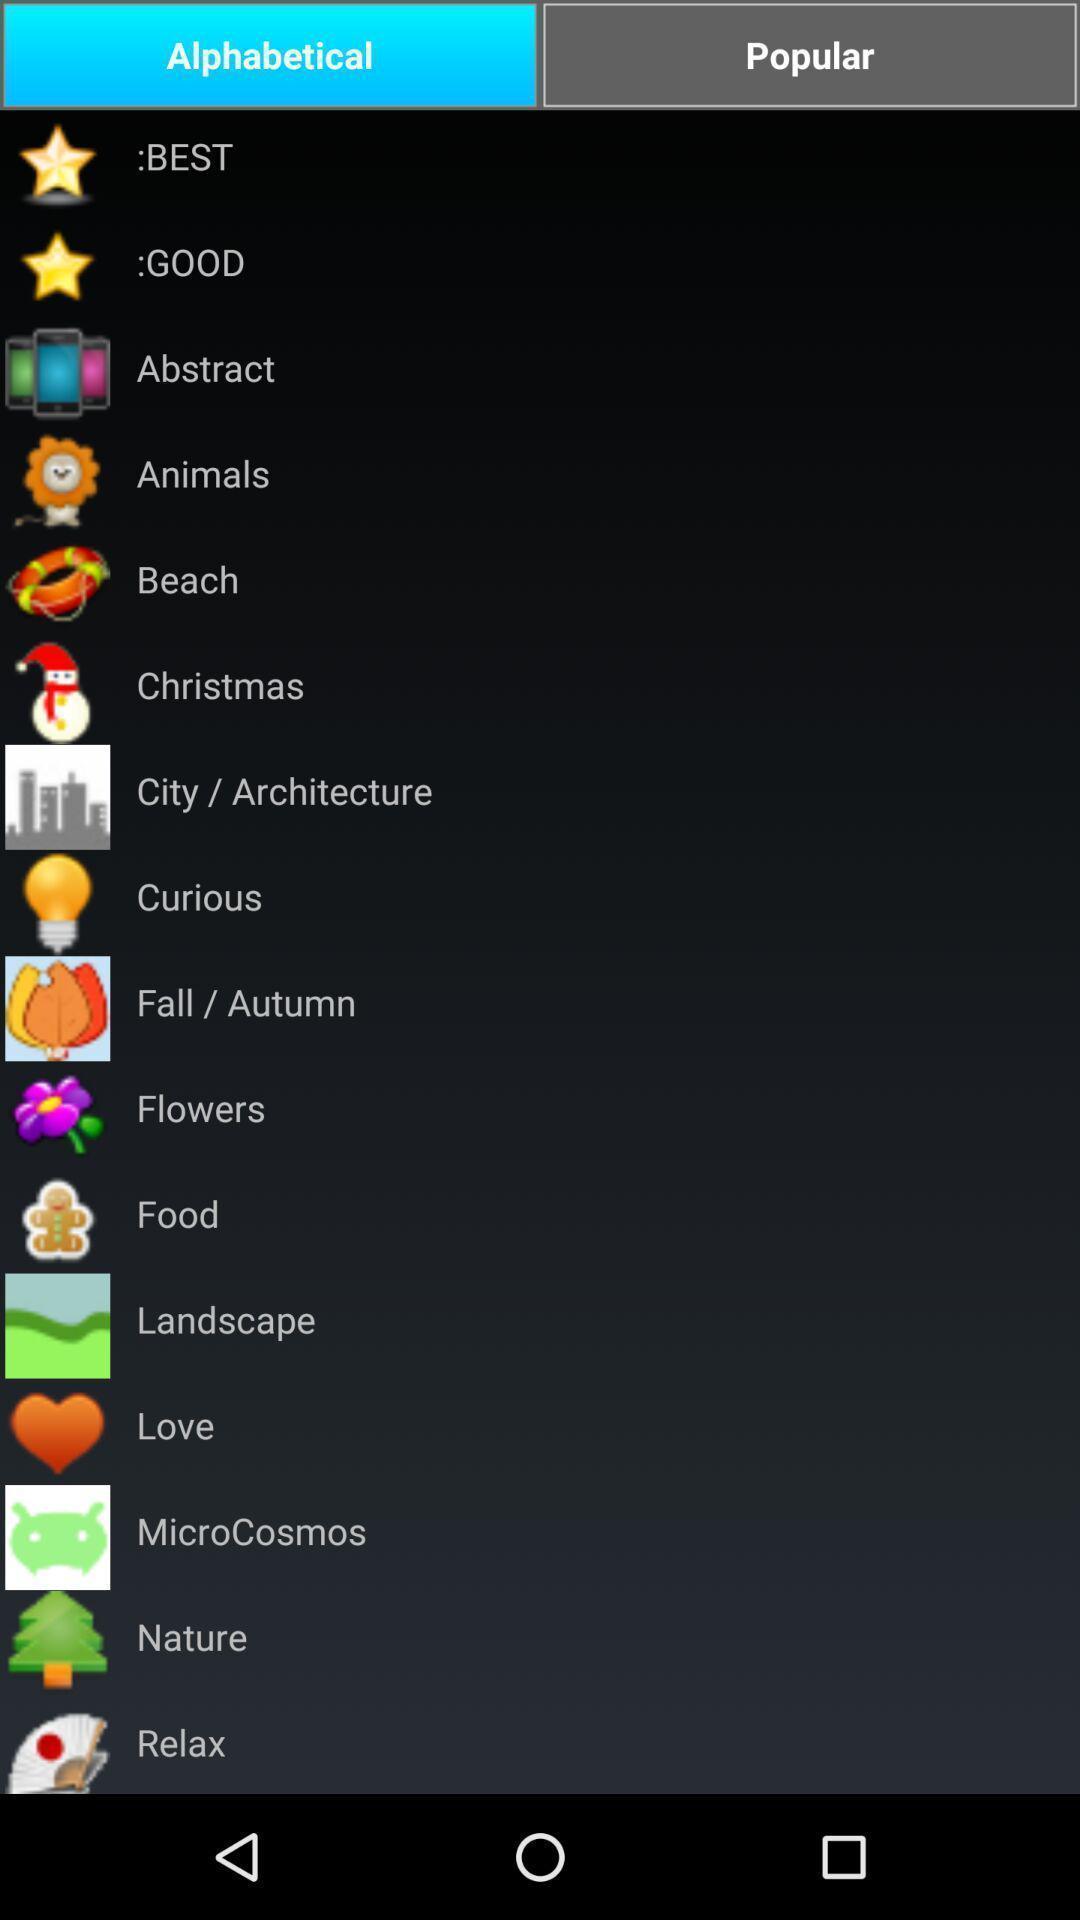Describe this image in words. Screen showing the multiple options in alphabetical tab. 